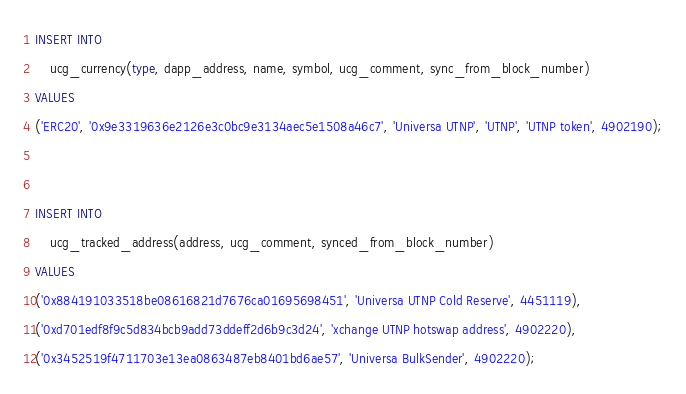Convert code to text. <code><loc_0><loc_0><loc_500><loc_500><_SQL_>INSERT INTO
    ucg_currency(type, dapp_address, name, symbol, ucg_comment, sync_from_block_number)
VALUES
('ERC20', '0x9e3319636e2126e3c0bc9e3134aec5e1508a46c7', 'Universa UTNP', 'UTNP', 'UTNP token', 4902190);


INSERT INTO
    ucg_tracked_address(address, ucg_comment, synced_from_block_number)
VALUES
('0x884191033518be08616821d7676ca01695698451', 'Universa UTNP Cold Reserve', 4451119),
('0xd701edf8f9c5d834bcb9add73ddeff2d6b9c3d24', 'xchange UTNP hotswap address', 4902220),
('0x3452519f4711703e13ea0863487eb8401bd6ae57', 'Universa BulkSender', 4902220);
</code> 